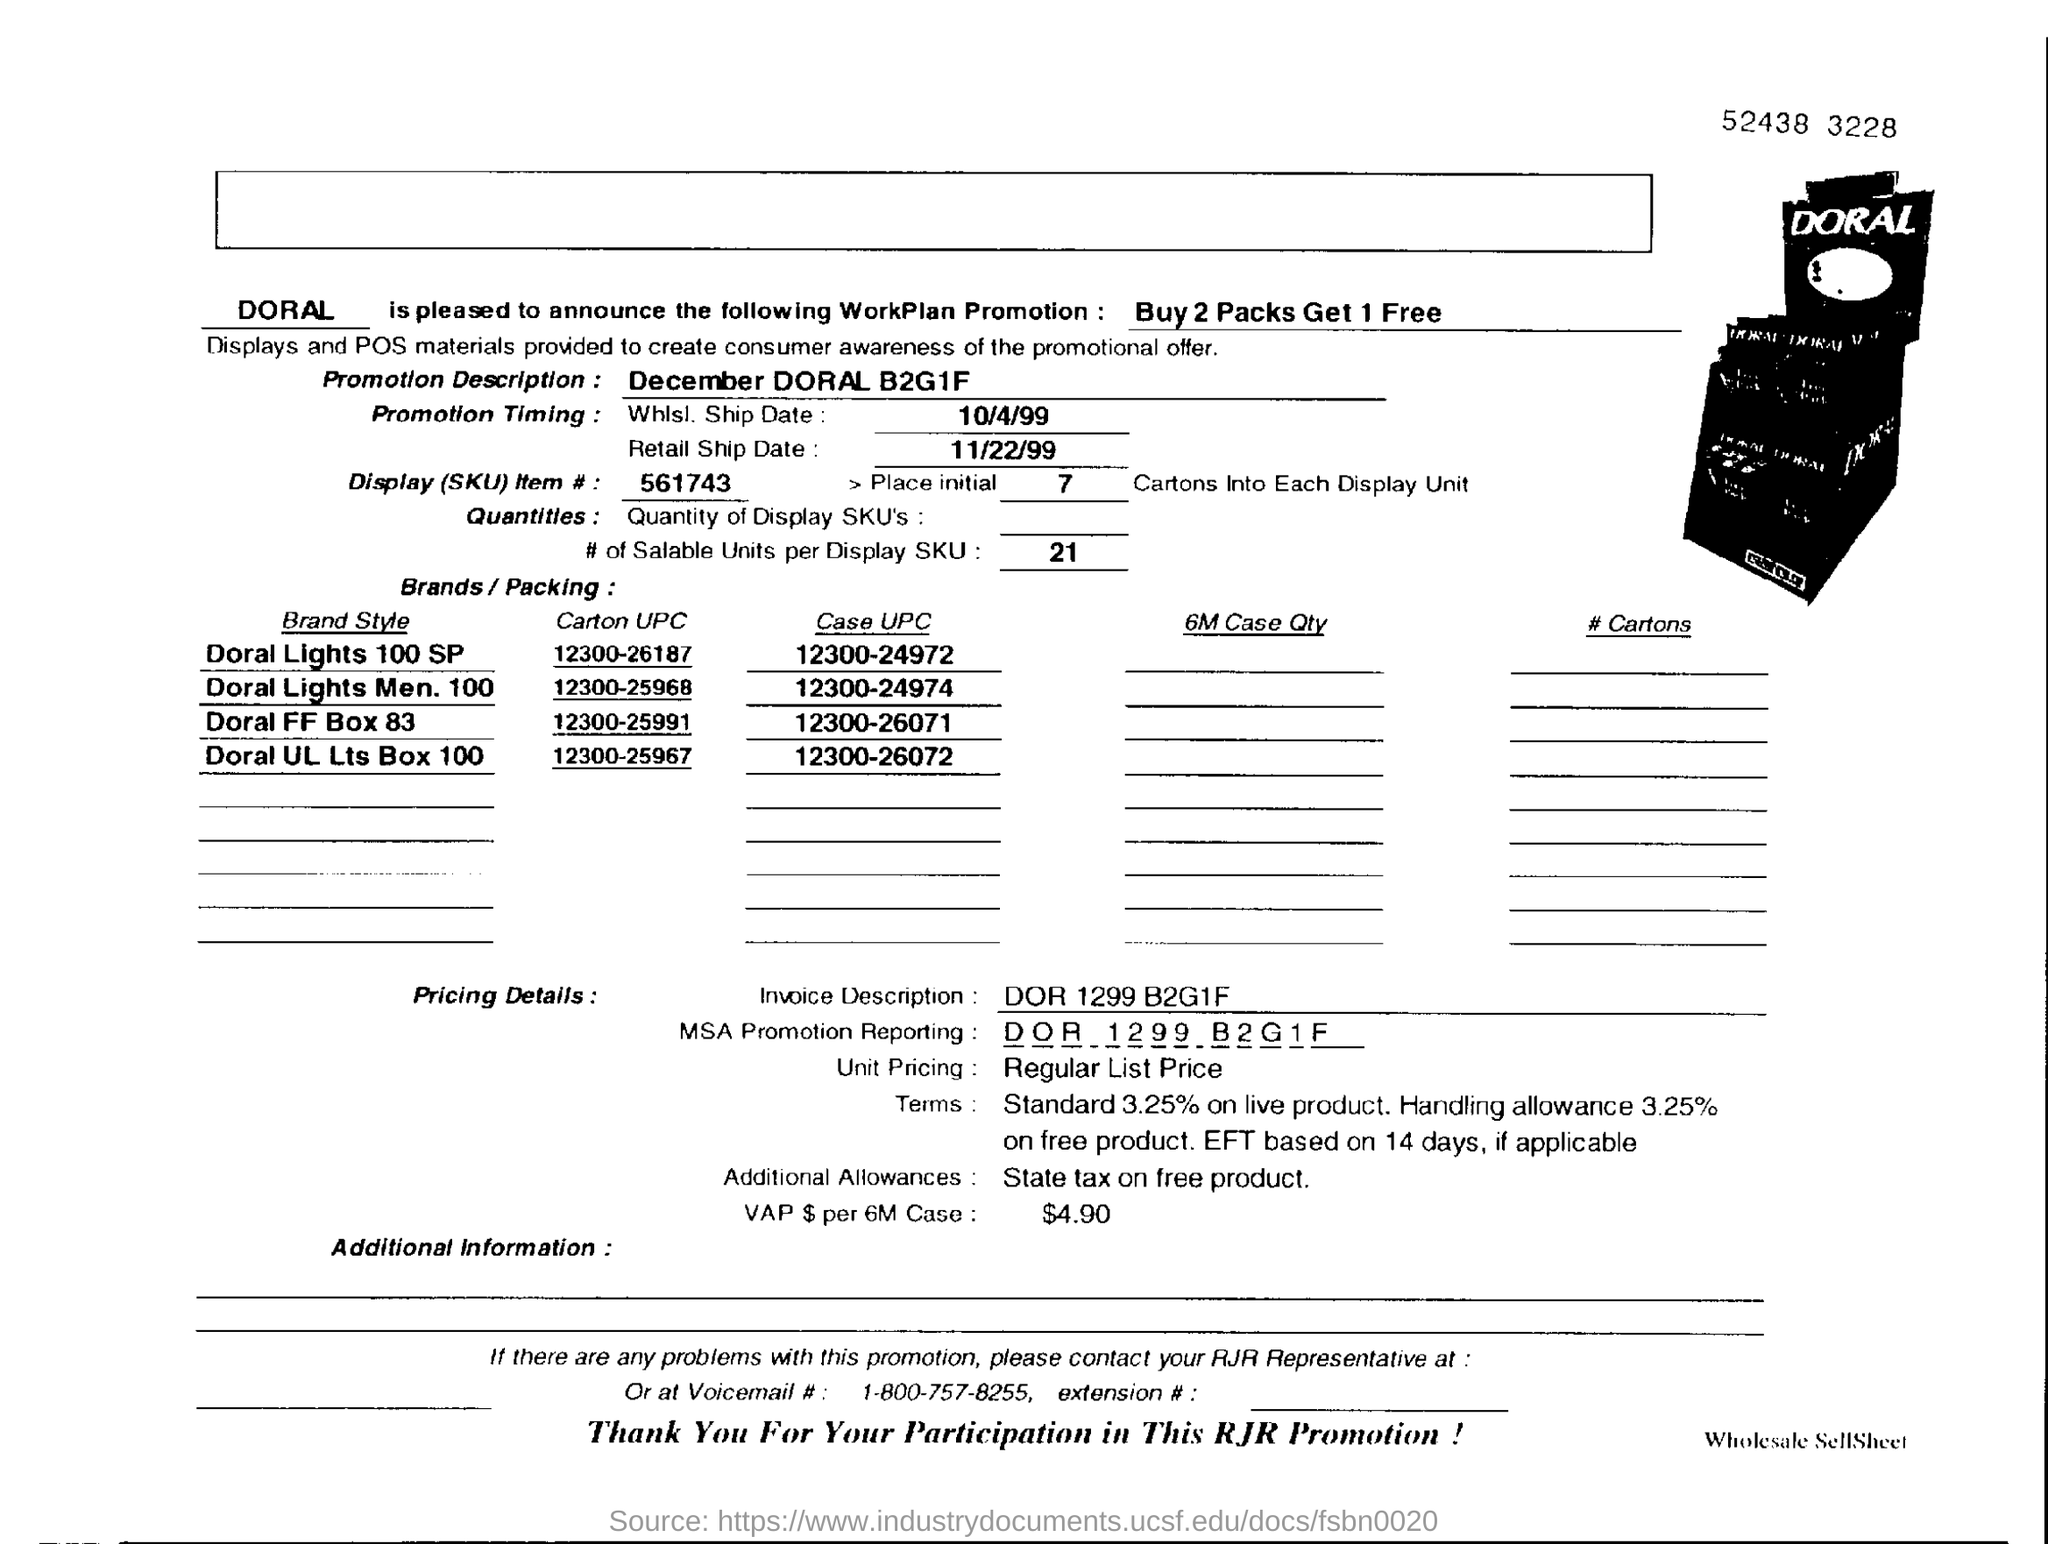Outline some significant characteristics in this image. What additional allowances are mentioned? State tax on free product... The cost of VAP per 6M cases is $4.90. The Carton UPC of Doral FF Box 83 is 12300-25991. December at Doral is offering a promotion where guests can enjoy buy-one-get-one-free admission for families, as well as a special discount for groups of four or more. The Display(SKU) Item number is 561743... 